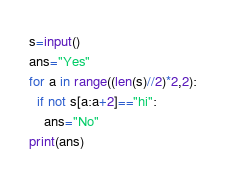Convert code to text. <code><loc_0><loc_0><loc_500><loc_500><_Python_>s=input()
ans="Yes"
for a in range((len(s)//2)*2,2):
  if not s[a:a+2]=="hi":
  	ans="No"
print(ans)
</code> 